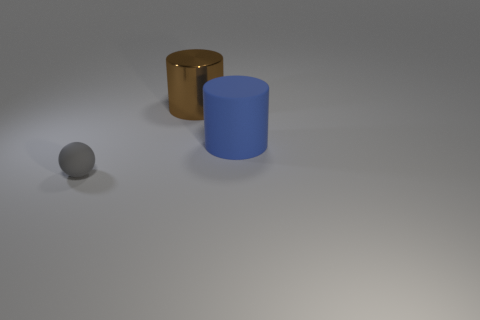Subtract all cylinders. How many objects are left? 1 Subtract all gray cubes. How many brown cylinders are left? 1 Add 1 blue matte things. How many objects exist? 4 Subtract all green cylinders. Subtract all purple cubes. How many cylinders are left? 2 Subtract all brown metallic cylinders. Subtract all tiny cyan balls. How many objects are left? 2 Add 1 large blue things. How many large blue things are left? 2 Add 2 big rubber cylinders. How many big rubber cylinders exist? 3 Subtract 1 gray balls. How many objects are left? 2 Subtract 1 balls. How many balls are left? 0 